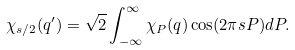Convert formula to latex. <formula><loc_0><loc_0><loc_500><loc_500>\chi _ { s / 2 } ( q ^ { \prime } ) = \sqrt { 2 } \int _ { - \infty } ^ { \infty } \chi _ { P } ( q ) \cos ( 2 \pi s P ) d P .</formula> 